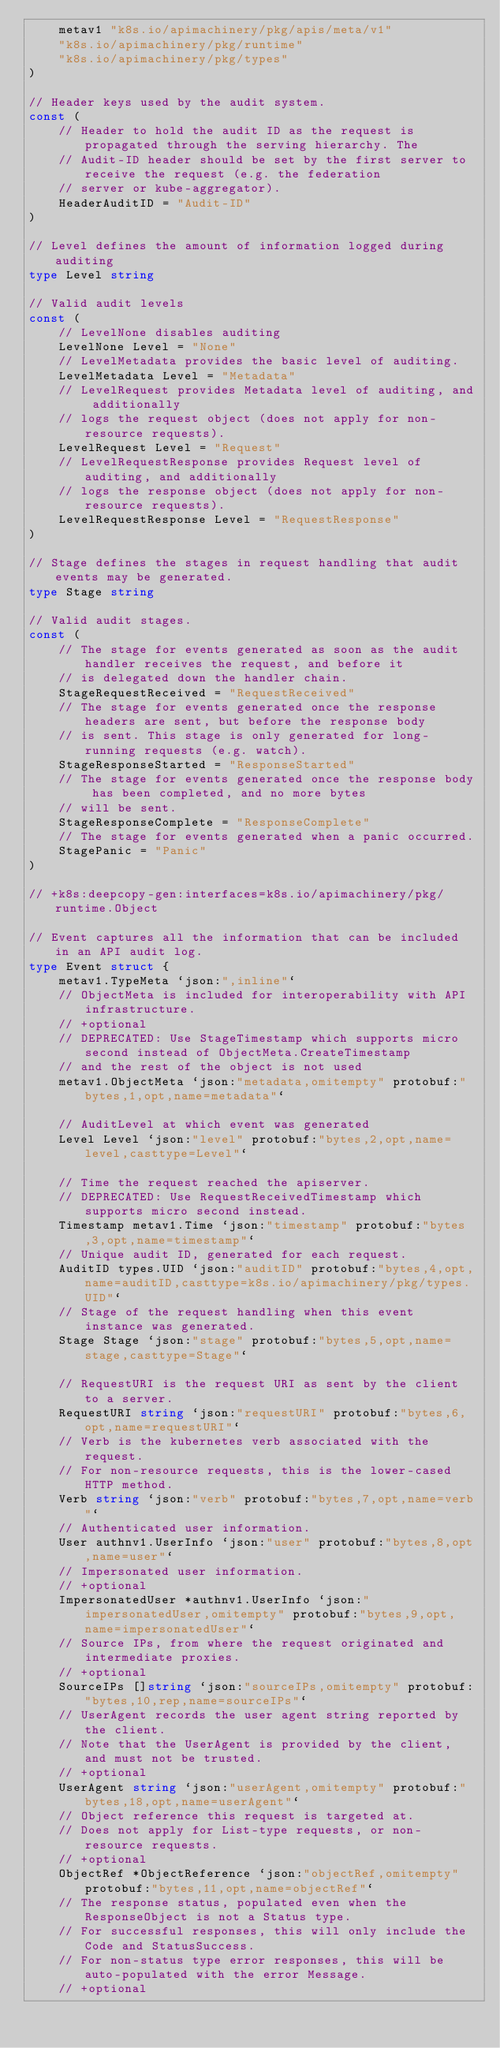<code> <loc_0><loc_0><loc_500><loc_500><_Go_>	metav1 "k8s.io/apimachinery/pkg/apis/meta/v1"
	"k8s.io/apimachinery/pkg/runtime"
	"k8s.io/apimachinery/pkg/types"
)

// Header keys used by the audit system.
const (
	// Header to hold the audit ID as the request is propagated through the serving hierarchy. The
	// Audit-ID header should be set by the first server to receive the request (e.g. the federation
	// server or kube-aggregator).
	HeaderAuditID = "Audit-ID"
)

// Level defines the amount of information logged during auditing
type Level string

// Valid audit levels
const (
	// LevelNone disables auditing
	LevelNone Level = "None"
	// LevelMetadata provides the basic level of auditing.
	LevelMetadata Level = "Metadata"
	// LevelRequest provides Metadata level of auditing, and additionally
	// logs the request object (does not apply for non-resource requests).
	LevelRequest Level = "Request"
	// LevelRequestResponse provides Request level of auditing, and additionally
	// logs the response object (does not apply for non-resource requests).
	LevelRequestResponse Level = "RequestResponse"
)

// Stage defines the stages in request handling that audit events may be generated.
type Stage string

// Valid audit stages.
const (
	// The stage for events generated as soon as the audit handler receives the request, and before it
	// is delegated down the handler chain.
	StageRequestReceived = "RequestReceived"
	// The stage for events generated once the response headers are sent, but before the response body
	// is sent. This stage is only generated for long-running requests (e.g. watch).
	StageResponseStarted = "ResponseStarted"
	// The stage for events generated once the response body has been completed, and no more bytes
	// will be sent.
	StageResponseComplete = "ResponseComplete"
	// The stage for events generated when a panic occurred.
	StagePanic = "Panic"
)

// +k8s:deepcopy-gen:interfaces=k8s.io/apimachinery/pkg/runtime.Object

// Event captures all the information that can be included in an API audit log.
type Event struct {
	metav1.TypeMeta `json:",inline"`
	// ObjectMeta is included for interoperability with API infrastructure.
	// +optional
	// DEPRECATED: Use StageTimestamp which supports micro second instead of ObjectMeta.CreateTimestamp
	// and the rest of the object is not used
	metav1.ObjectMeta `json:"metadata,omitempty" protobuf:"bytes,1,opt,name=metadata"`

	// AuditLevel at which event was generated
	Level Level `json:"level" protobuf:"bytes,2,opt,name=level,casttype=Level"`

	// Time the request reached the apiserver.
	// DEPRECATED: Use RequestReceivedTimestamp which supports micro second instead.
	Timestamp metav1.Time `json:"timestamp" protobuf:"bytes,3,opt,name=timestamp"`
	// Unique audit ID, generated for each request.
	AuditID types.UID `json:"auditID" protobuf:"bytes,4,opt,name=auditID,casttype=k8s.io/apimachinery/pkg/types.UID"`
	// Stage of the request handling when this event instance was generated.
	Stage Stage `json:"stage" protobuf:"bytes,5,opt,name=stage,casttype=Stage"`

	// RequestURI is the request URI as sent by the client to a server.
	RequestURI string `json:"requestURI" protobuf:"bytes,6,opt,name=requestURI"`
	// Verb is the kubernetes verb associated with the request.
	// For non-resource requests, this is the lower-cased HTTP method.
	Verb string `json:"verb" protobuf:"bytes,7,opt,name=verb"`
	// Authenticated user information.
	User authnv1.UserInfo `json:"user" protobuf:"bytes,8,opt,name=user"`
	// Impersonated user information.
	// +optional
	ImpersonatedUser *authnv1.UserInfo `json:"impersonatedUser,omitempty" protobuf:"bytes,9,opt,name=impersonatedUser"`
	// Source IPs, from where the request originated and intermediate proxies.
	// +optional
	SourceIPs []string `json:"sourceIPs,omitempty" protobuf:"bytes,10,rep,name=sourceIPs"`
	// UserAgent records the user agent string reported by the client.
	// Note that the UserAgent is provided by the client, and must not be trusted.
	// +optional
	UserAgent string `json:"userAgent,omitempty" protobuf:"bytes,18,opt,name=userAgent"`
	// Object reference this request is targeted at.
	// Does not apply for List-type requests, or non-resource requests.
	// +optional
	ObjectRef *ObjectReference `json:"objectRef,omitempty" protobuf:"bytes,11,opt,name=objectRef"`
	// The response status, populated even when the ResponseObject is not a Status type.
	// For successful responses, this will only include the Code and StatusSuccess.
	// For non-status type error responses, this will be auto-populated with the error Message.
	// +optional</code> 